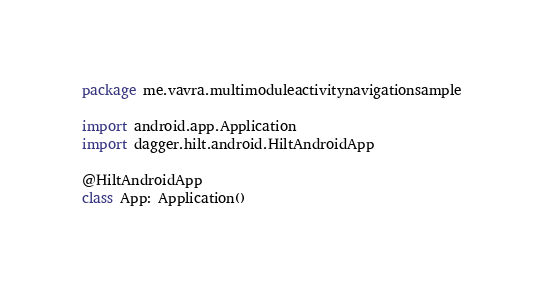Convert code to text. <code><loc_0><loc_0><loc_500><loc_500><_Kotlin_>package me.vavra.multimoduleactivitynavigationsample

import android.app.Application
import dagger.hilt.android.HiltAndroidApp

@HiltAndroidApp
class App: Application()</code> 